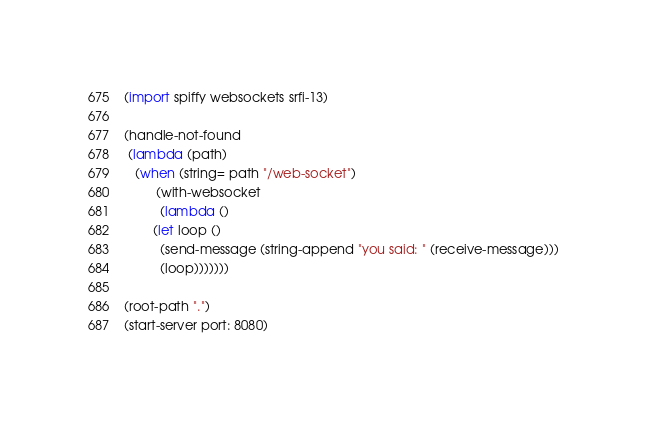Convert code to text. <code><loc_0><loc_0><loc_500><loc_500><_Scheme_>(import spiffy websockets srfi-13)

(handle-not-found
 (lambda (path)
   (when (string= path "/web-socket")
         (with-websocket
          (lambda ()
	    (let loop ()
	      (send-message (string-append "you said: " (receive-message)))
	      (loop)))))))

(root-path ".")
(start-server port: 8080)
</code> 